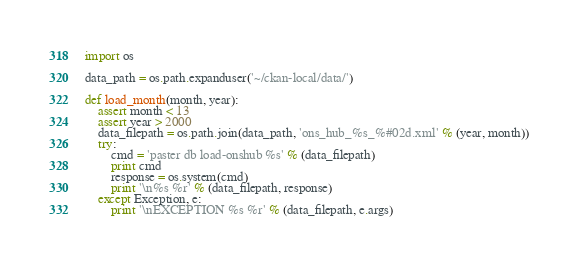Convert code to text. <code><loc_0><loc_0><loc_500><loc_500><_Python_>import os

data_path = os.path.expanduser('~/ckan-local/data/')

def load_month(month, year):
    assert month < 13
    assert year > 2000
    data_filepath = os.path.join(data_path, 'ons_hub_%s_%#02d.xml' % (year, month))
    try:
        cmd = 'paster db load-onshub %s' % (data_filepath)
        print cmd
        response = os.system(cmd)
        print '\n%s %r' % (data_filepath, response)
    except Exception, e:
        print '\nEXCEPTION %s %r' % (data_filepath, e.args)

</code> 